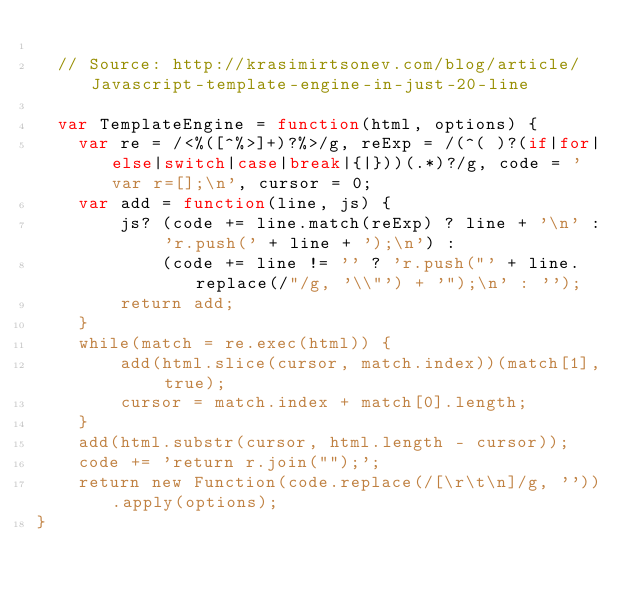Convert code to text. <code><loc_0><loc_0><loc_500><loc_500><_JavaScript_>
  // Source: http://krasimirtsonev.com/blog/article/Javascript-template-engine-in-just-20-line

  var TemplateEngine = function(html, options) {
    var re = /<%([^%>]+)?%>/g, reExp = /(^( )?(if|for|else|switch|case|break|{|}))(.*)?/g, code = 'var r=[];\n', cursor = 0;
    var add = function(line, js) {
        js? (code += line.match(reExp) ? line + '\n' : 'r.push(' + line + ');\n') :
            (code += line != '' ? 'r.push("' + line.replace(/"/g, '\\"') + '");\n' : '');
        return add;
    }
    while(match = re.exec(html)) {
        add(html.slice(cursor, match.index))(match[1], true);
        cursor = match.index + match[0].length;
    }
    add(html.substr(cursor, html.length - cursor));
    code += 'return r.join("");';
    return new Function(code.replace(/[\r\t\n]/g, '')).apply(options);
}</code> 